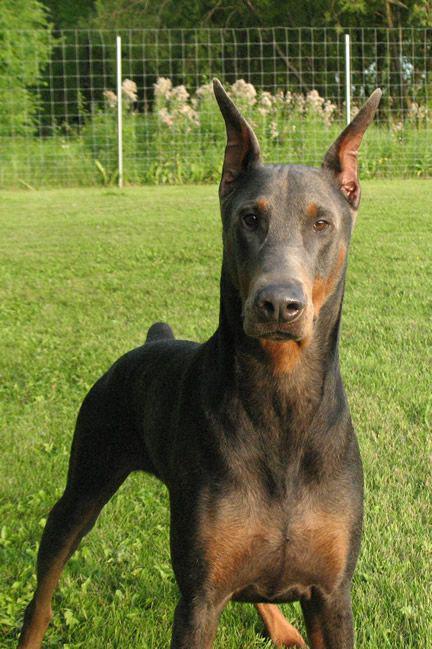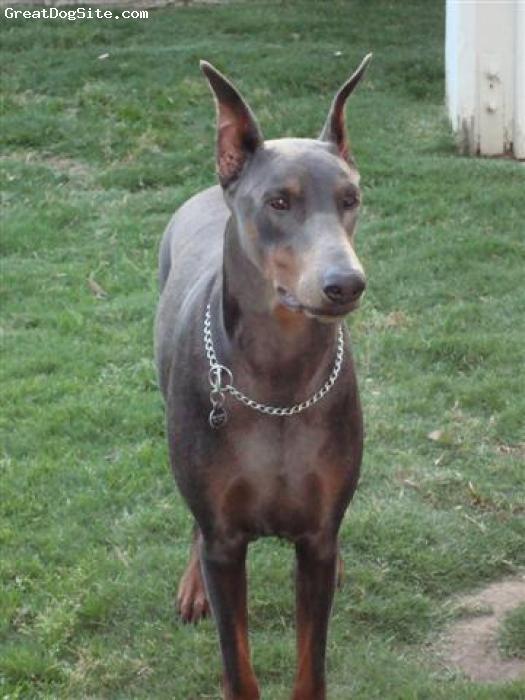The first image is the image on the left, the second image is the image on the right. For the images displayed, is the sentence "There is only one dog in each image and it has a collar on." factually correct? Answer yes or no. No. The first image is the image on the left, the second image is the image on the right. Assess this claim about the two images: "There is only one dog in each picture and both have similar positions.". Correct or not? Answer yes or no. Yes. 